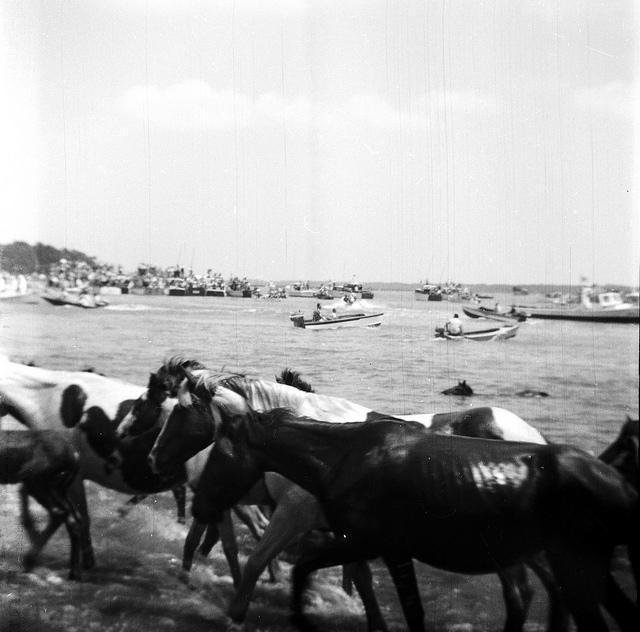How many horses are there?
Give a very brief answer. 5. 